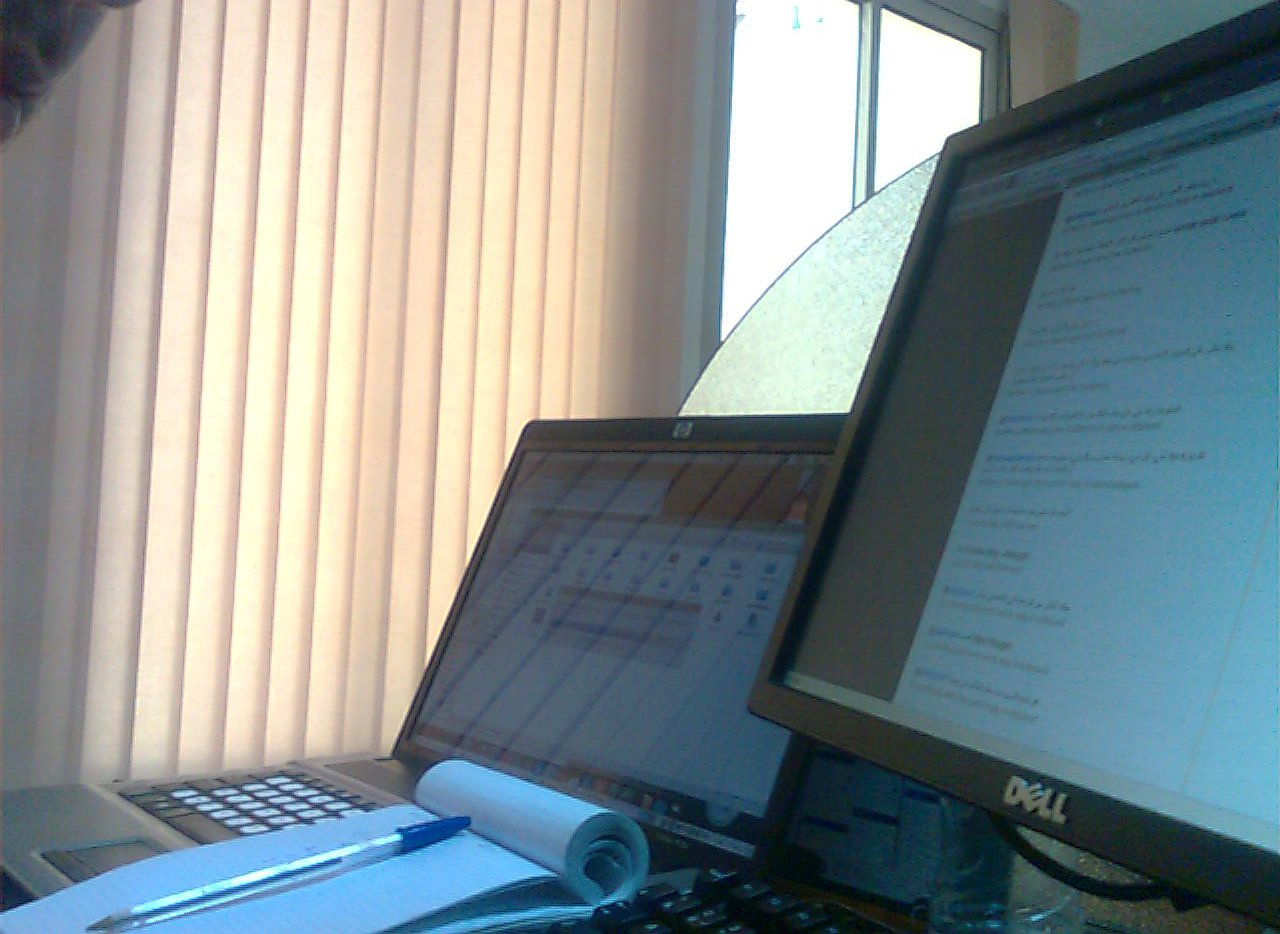What device is not black, the keyboard or the computer monitor? The keyboard is not black, featuring a lighter grey color which stands in contrast to the distinctly black computer monitor. 